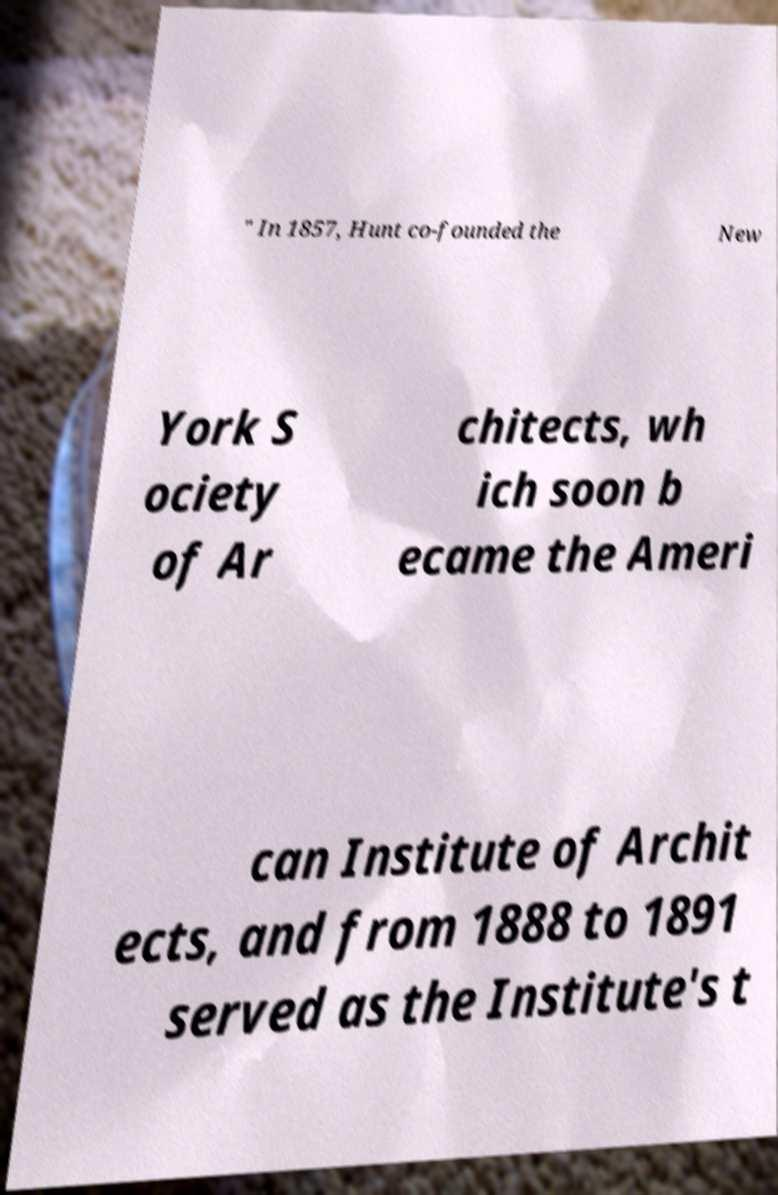Could you extract and type out the text from this image? " In 1857, Hunt co-founded the New York S ociety of Ar chitects, wh ich soon b ecame the Ameri can Institute of Archit ects, and from 1888 to 1891 served as the Institute's t 